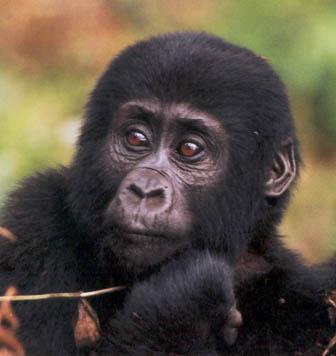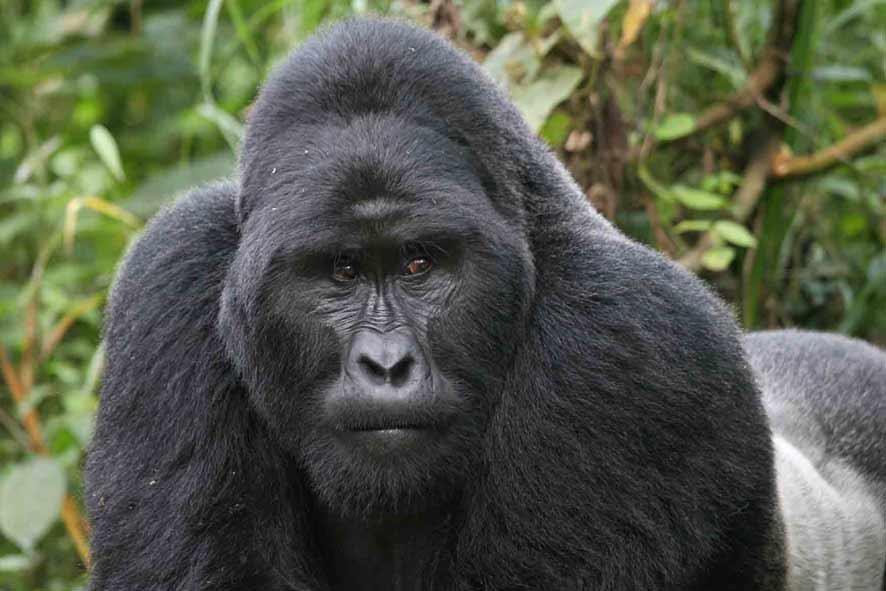The first image is the image on the left, the second image is the image on the right. For the images displayed, is the sentence "In one image is an adult gorilla alone." factually correct? Answer yes or no. Yes. The first image is the image on the left, the second image is the image on the right. Examine the images to the left and right. Is the description "The right image contains only a baby gorilla with a shock of hair on its head, and the left image includes a baby gorilla on the front of an adult gorilla." accurate? Answer yes or no. No. 